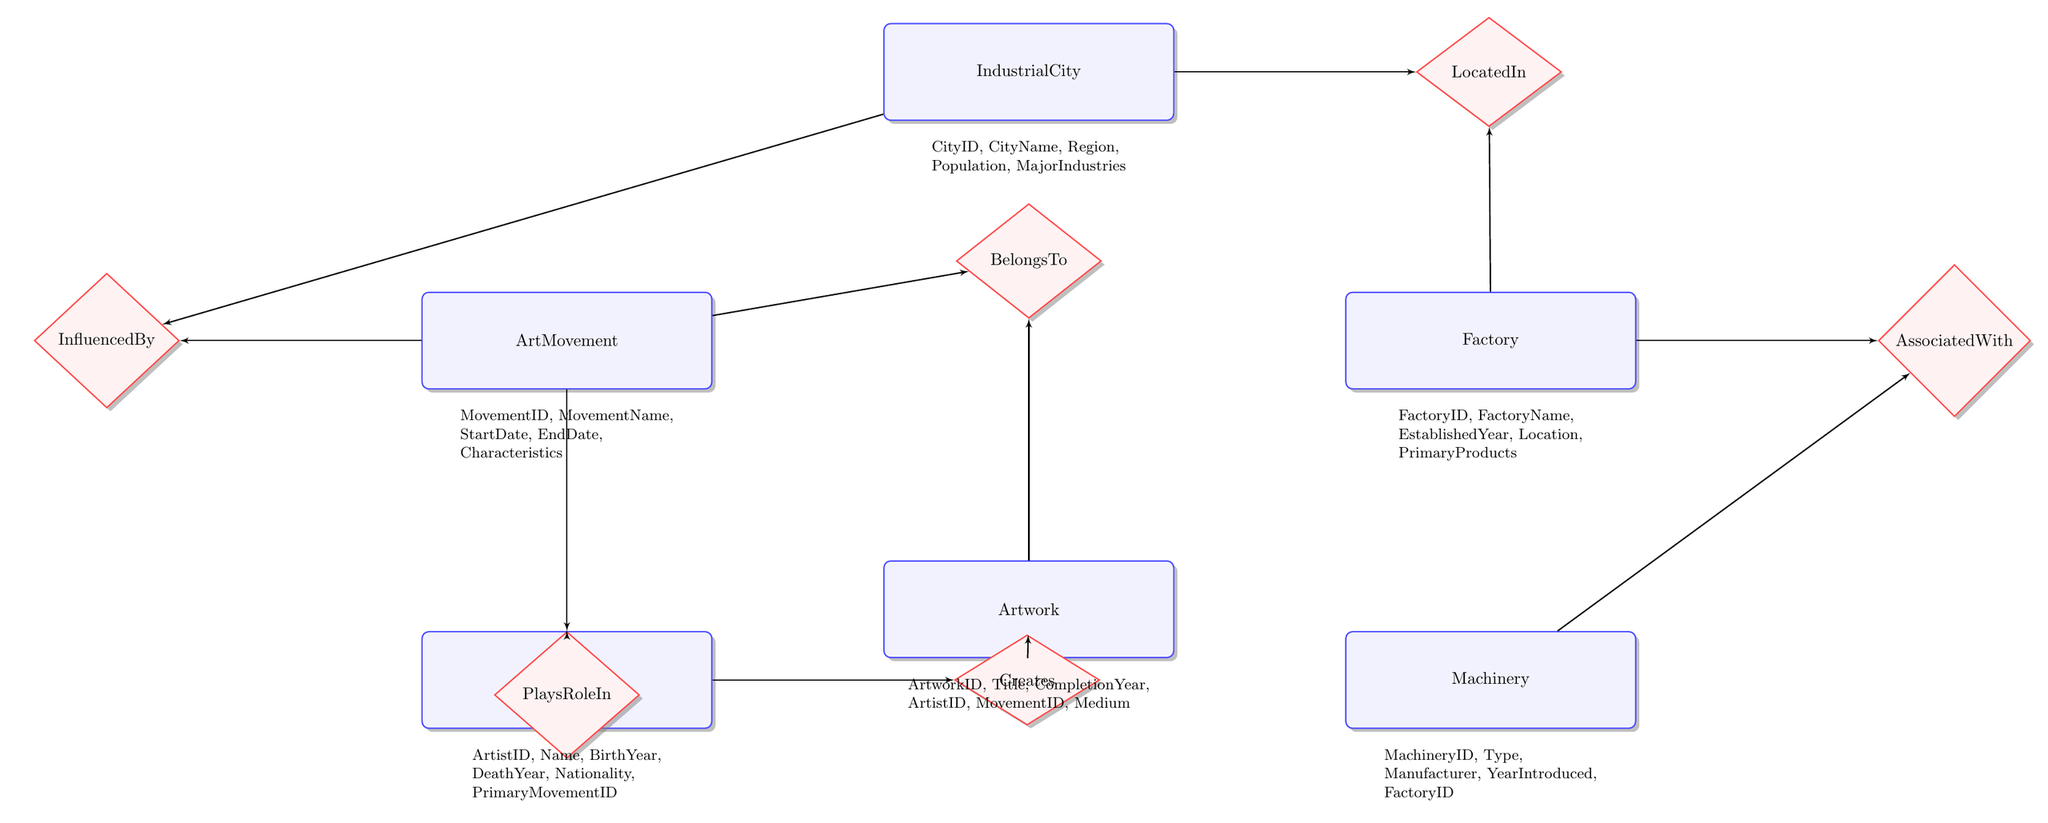What are the attributes of the IndustrialCity entity? The IndustrialCity entity has five attributes: CityID, CityName, Region, Population, and MajorIndustries.
Answer: CityID, CityName, Region, Population, MajorIndustries How many entities are present in the diagram? The diagram includes six entities: IndustrialCity, Factory, Machinery, ArtMovement, Artist, and Artwork, which totals to six entities.
Answer: 6 What is the relationship between Factory and IndustrialCity? The relationship between Factory and IndustrialCity is labeled as "LocatedIn". This indicates that a factory is situated within an industrial city.
Answer: LocatedIn Which entity is influenced by the IndustrialCity? The entity that is influenced by IndustrialCity is the ArtMovement. The connection is defined by the "InfluencedBy" relationship.
Answer: ArtMovement What role does the Artist play in relation to the ArtMovement? The Artist is connected to the ArtMovement through the "PlaysRoleIn" relationship, indicating a participatory relationship between the two entities.
Answer: PlaysRoleIn How many relationships connect the Factory and Machinery entities? There is one relationship connecting the Factory and Machinery entities, which is labeled as "AssociatedWith".
Answer: 1 What is the primary purpose of the artwork in relation to the Artist? The primary purpose of the artwork in relation to the Artist is defined by the "Creates" relationship, indicating that an artist creates a specific artwork.
Answer: Creates Which entity directly connects to the Artwork entity? The Artwork entity directly connects to both the Artist and the ArtMovement entities through the "Creates" and "BelongsTo" relationships, respectively.
Answer: Artist, ArtMovement What is the main characteristic of the relationship defined as "InfluencedBy"? The "InfluencedBy" relationship indicates that one entity (the ArtMovement) is shaped or affected by another entity (the IndustrialCity).
Answer: InfluencedBy What type of information does the Machinery entity represent? The Machinery entity represents information regarding types of machinery used in factories, including attributes like Type, Manufacturer, YearIntroduced, and FactoryID.
Answer: Type, Manufacturer, YearIntroduced, FactoryID 